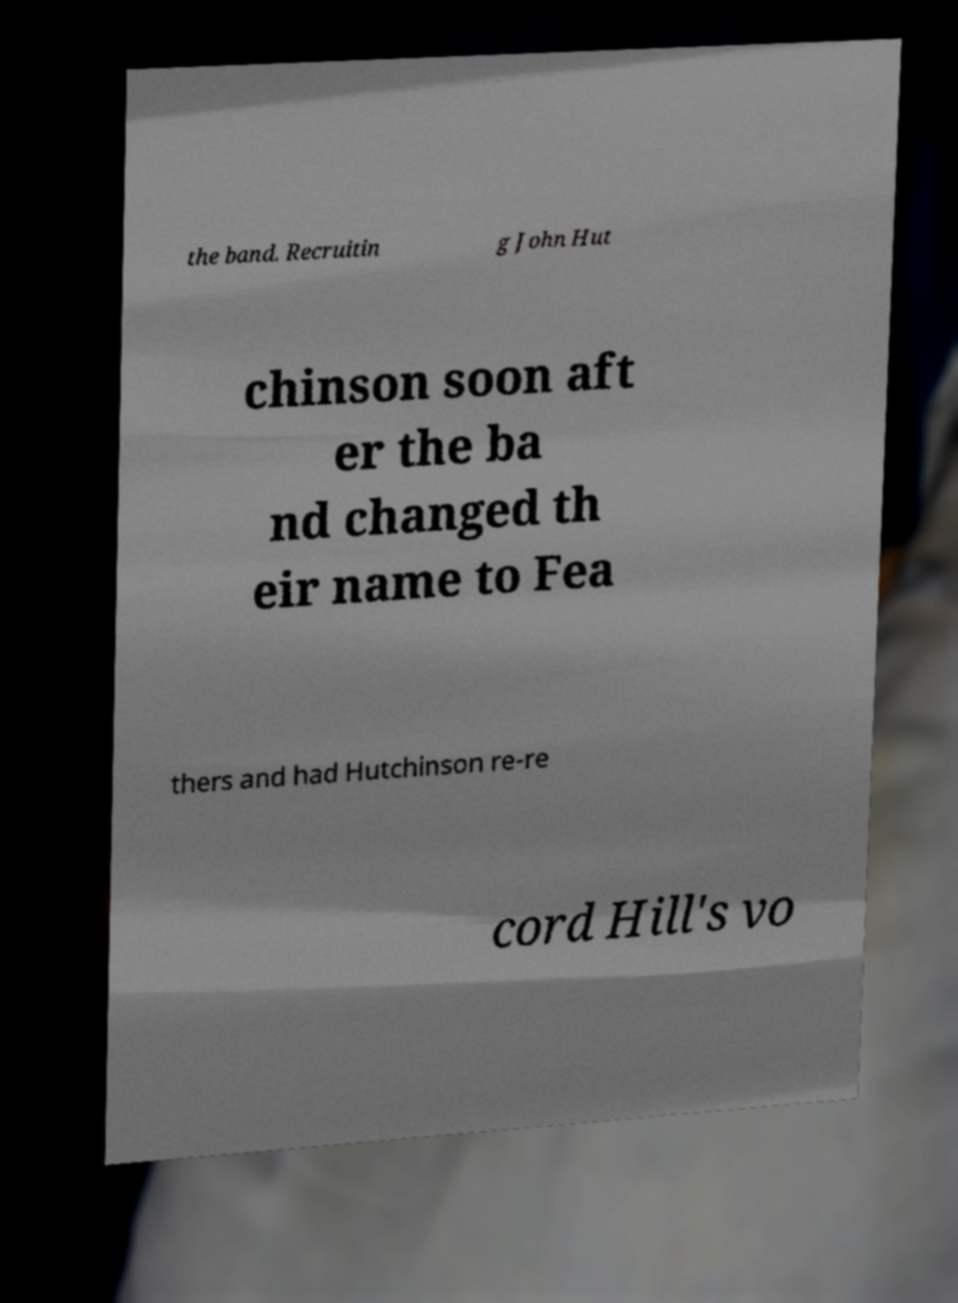Please identify and transcribe the text found in this image. the band. Recruitin g John Hut chinson soon aft er the ba nd changed th eir name to Fea thers and had Hutchinson re-re cord Hill's vo 